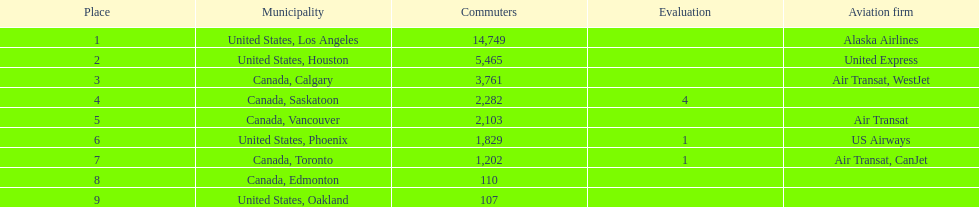Which airline carries the most passengers? Alaska Airlines. 